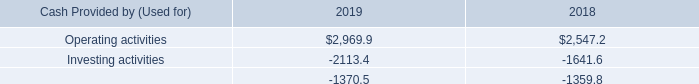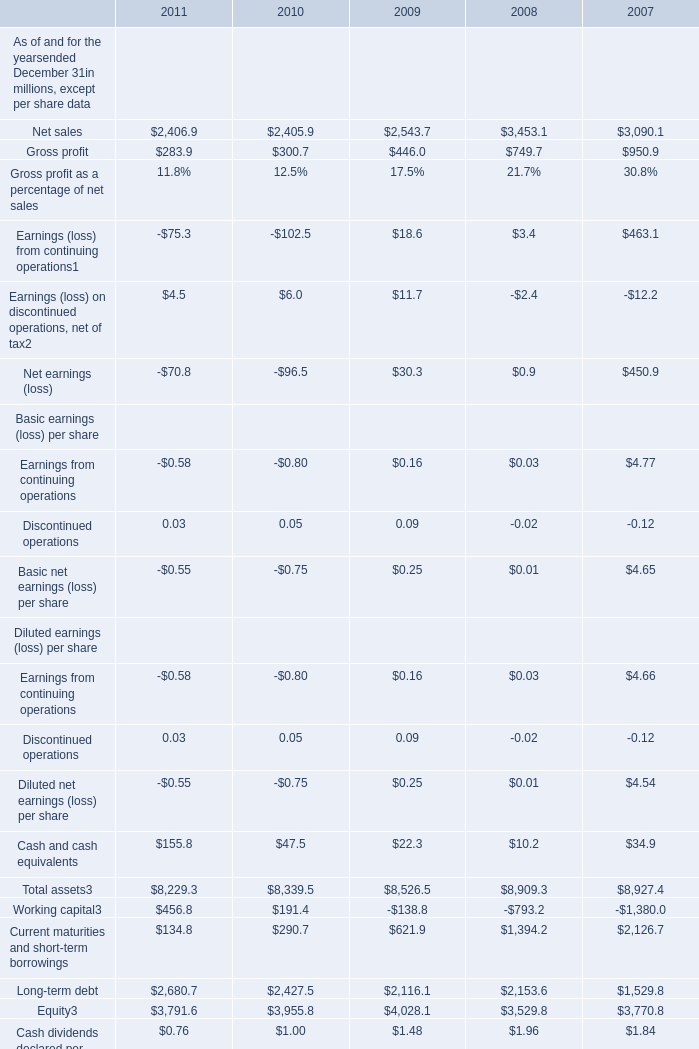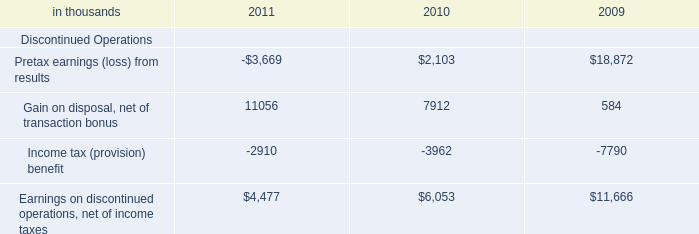What is the growing rate of Gross profit in Table 1 in the years with the least Pretax earnings (loss) from results in Table 2? 
Computations: ((283.9 - 300.7) / 300.7)
Answer: -0.05587. 